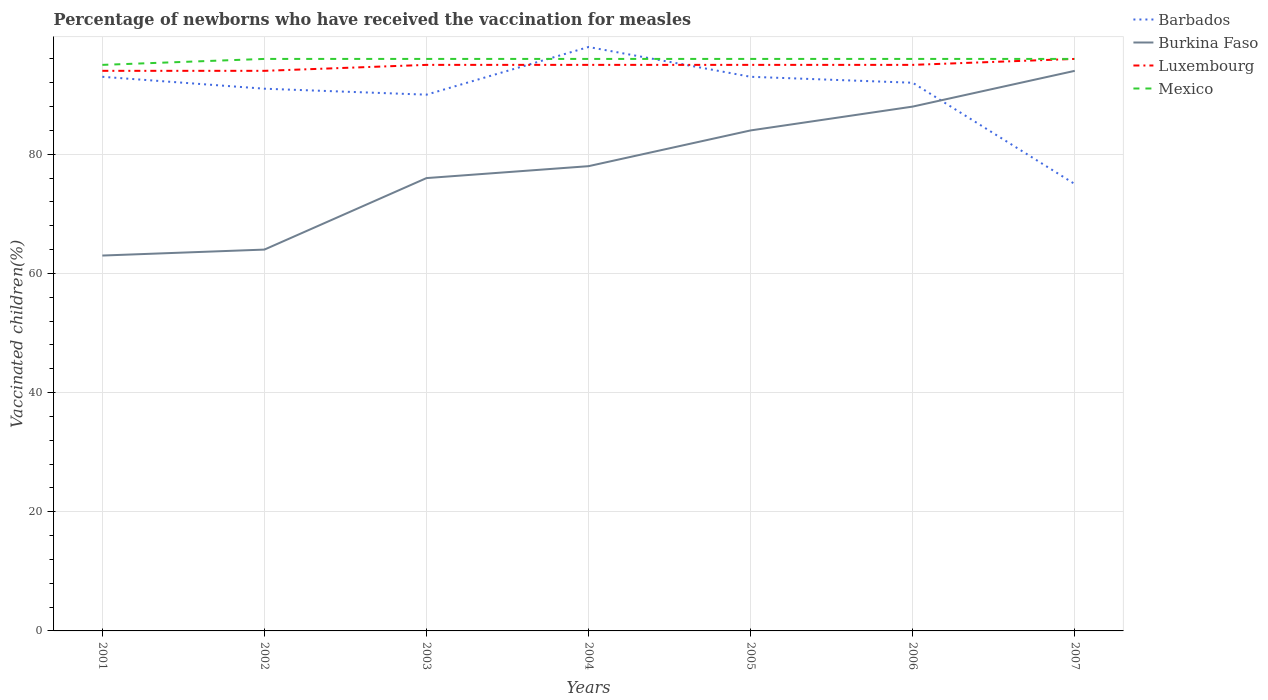Does the line corresponding to Mexico intersect with the line corresponding to Barbados?
Offer a very short reply. Yes. Across all years, what is the maximum percentage of vaccinated children in Barbados?
Give a very brief answer. 75. In which year was the percentage of vaccinated children in Mexico maximum?
Provide a short and direct response. 2001. What is the total percentage of vaccinated children in Mexico in the graph?
Make the answer very short. 0. What is the difference between the highest and the second highest percentage of vaccinated children in Mexico?
Your answer should be compact. 1. What is the difference between the highest and the lowest percentage of vaccinated children in Luxembourg?
Provide a short and direct response. 5. Is the percentage of vaccinated children in Burkina Faso strictly greater than the percentage of vaccinated children in Mexico over the years?
Offer a very short reply. Yes. How many years are there in the graph?
Provide a succinct answer. 7. Are the values on the major ticks of Y-axis written in scientific E-notation?
Your response must be concise. No. Does the graph contain grids?
Give a very brief answer. Yes. Where does the legend appear in the graph?
Your answer should be compact. Top right. How many legend labels are there?
Provide a short and direct response. 4. What is the title of the graph?
Ensure brevity in your answer.  Percentage of newborns who have received the vaccination for measles. What is the label or title of the X-axis?
Your answer should be compact. Years. What is the label or title of the Y-axis?
Provide a short and direct response. Vaccinated children(%). What is the Vaccinated children(%) in Barbados in 2001?
Make the answer very short. 93. What is the Vaccinated children(%) of Luxembourg in 2001?
Keep it short and to the point. 94. What is the Vaccinated children(%) in Barbados in 2002?
Offer a terse response. 91. What is the Vaccinated children(%) of Burkina Faso in 2002?
Offer a terse response. 64. What is the Vaccinated children(%) of Luxembourg in 2002?
Give a very brief answer. 94. What is the Vaccinated children(%) of Mexico in 2002?
Your answer should be compact. 96. What is the Vaccinated children(%) in Barbados in 2003?
Your answer should be very brief. 90. What is the Vaccinated children(%) in Mexico in 2003?
Keep it short and to the point. 96. What is the Vaccinated children(%) of Barbados in 2004?
Make the answer very short. 98. What is the Vaccinated children(%) of Luxembourg in 2004?
Give a very brief answer. 95. What is the Vaccinated children(%) in Mexico in 2004?
Make the answer very short. 96. What is the Vaccinated children(%) in Barbados in 2005?
Ensure brevity in your answer.  93. What is the Vaccinated children(%) in Mexico in 2005?
Provide a short and direct response. 96. What is the Vaccinated children(%) of Barbados in 2006?
Your response must be concise. 92. What is the Vaccinated children(%) of Luxembourg in 2006?
Your answer should be compact. 95. What is the Vaccinated children(%) of Mexico in 2006?
Ensure brevity in your answer.  96. What is the Vaccinated children(%) of Burkina Faso in 2007?
Offer a terse response. 94. What is the Vaccinated children(%) of Luxembourg in 2007?
Offer a very short reply. 96. What is the Vaccinated children(%) of Mexico in 2007?
Your answer should be very brief. 96. Across all years, what is the maximum Vaccinated children(%) in Burkina Faso?
Give a very brief answer. 94. Across all years, what is the maximum Vaccinated children(%) of Luxembourg?
Provide a short and direct response. 96. Across all years, what is the maximum Vaccinated children(%) in Mexico?
Offer a terse response. 96. Across all years, what is the minimum Vaccinated children(%) in Burkina Faso?
Your response must be concise. 63. Across all years, what is the minimum Vaccinated children(%) of Luxembourg?
Give a very brief answer. 94. Across all years, what is the minimum Vaccinated children(%) in Mexico?
Offer a terse response. 95. What is the total Vaccinated children(%) of Barbados in the graph?
Give a very brief answer. 632. What is the total Vaccinated children(%) of Burkina Faso in the graph?
Your answer should be compact. 547. What is the total Vaccinated children(%) in Luxembourg in the graph?
Your response must be concise. 664. What is the total Vaccinated children(%) in Mexico in the graph?
Give a very brief answer. 671. What is the difference between the Vaccinated children(%) in Barbados in 2001 and that in 2002?
Provide a short and direct response. 2. What is the difference between the Vaccinated children(%) of Luxembourg in 2001 and that in 2002?
Keep it short and to the point. 0. What is the difference between the Vaccinated children(%) in Mexico in 2001 and that in 2002?
Provide a succinct answer. -1. What is the difference between the Vaccinated children(%) in Barbados in 2001 and that in 2003?
Provide a succinct answer. 3. What is the difference between the Vaccinated children(%) in Barbados in 2001 and that in 2004?
Give a very brief answer. -5. What is the difference between the Vaccinated children(%) in Luxembourg in 2001 and that in 2004?
Your answer should be compact. -1. What is the difference between the Vaccinated children(%) of Mexico in 2001 and that in 2004?
Your response must be concise. -1. What is the difference between the Vaccinated children(%) of Burkina Faso in 2001 and that in 2005?
Your answer should be very brief. -21. What is the difference between the Vaccinated children(%) of Luxembourg in 2001 and that in 2005?
Your answer should be very brief. -1. What is the difference between the Vaccinated children(%) of Mexico in 2001 and that in 2005?
Your answer should be compact. -1. What is the difference between the Vaccinated children(%) of Luxembourg in 2001 and that in 2006?
Ensure brevity in your answer.  -1. What is the difference between the Vaccinated children(%) in Mexico in 2001 and that in 2006?
Provide a succinct answer. -1. What is the difference between the Vaccinated children(%) in Burkina Faso in 2001 and that in 2007?
Provide a short and direct response. -31. What is the difference between the Vaccinated children(%) in Luxembourg in 2001 and that in 2007?
Your response must be concise. -2. What is the difference between the Vaccinated children(%) of Barbados in 2002 and that in 2003?
Provide a succinct answer. 1. What is the difference between the Vaccinated children(%) in Mexico in 2002 and that in 2003?
Make the answer very short. 0. What is the difference between the Vaccinated children(%) of Barbados in 2002 and that in 2004?
Give a very brief answer. -7. What is the difference between the Vaccinated children(%) in Burkina Faso in 2002 and that in 2004?
Your answer should be very brief. -14. What is the difference between the Vaccinated children(%) in Barbados in 2002 and that in 2005?
Give a very brief answer. -2. What is the difference between the Vaccinated children(%) of Luxembourg in 2002 and that in 2005?
Make the answer very short. -1. What is the difference between the Vaccinated children(%) in Mexico in 2002 and that in 2005?
Provide a short and direct response. 0. What is the difference between the Vaccinated children(%) of Barbados in 2002 and that in 2006?
Provide a succinct answer. -1. What is the difference between the Vaccinated children(%) of Luxembourg in 2002 and that in 2006?
Provide a succinct answer. -1. What is the difference between the Vaccinated children(%) in Barbados in 2002 and that in 2007?
Offer a very short reply. 16. What is the difference between the Vaccinated children(%) in Mexico in 2002 and that in 2007?
Keep it short and to the point. 0. What is the difference between the Vaccinated children(%) of Burkina Faso in 2003 and that in 2004?
Ensure brevity in your answer.  -2. What is the difference between the Vaccinated children(%) in Luxembourg in 2003 and that in 2004?
Provide a short and direct response. 0. What is the difference between the Vaccinated children(%) in Mexico in 2003 and that in 2004?
Offer a terse response. 0. What is the difference between the Vaccinated children(%) of Barbados in 2003 and that in 2005?
Your response must be concise. -3. What is the difference between the Vaccinated children(%) of Burkina Faso in 2003 and that in 2006?
Offer a very short reply. -12. What is the difference between the Vaccinated children(%) of Mexico in 2003 and that in 2006?
Keep it short and to the point. 0. What is the difference between the Vaccinated children(%) in Barbados in 2003 and that in 2007?
Keep it short and to the point. 15. What is the difference between the Vaccinated children(%) in Burkina Faso in 2003 and that in 2007?
Your answer should be very brief. -18. What is the difference between the Vaccinated children(%) in Luxembourg in 2004 and that in 2005?
Provide a succinct answer. 0. What is the difference between the Vaccinated children(%) in Mexico in 2004 and that in 2005?
Keep it short and to the point. 0. What is the difference between the Vaccinated children(%) of Burkina Faso in 2004 and that in 2006?
Provide a short and direct response. -10. What is the difference between the Vaccinated children(%) in Luxembourg in 2004 and that in 2006?
Provide a succinct answer. 0. What is the difference between the Vaccinated children(%) in Mexico in 2004 and that in 2006?
Offer a terse response. 0. What is the difference between the Vaccinated children(%) in Mexico in 2004 and that in 2007?
Ensure brevity in your answer.  0. What is the difference between the Vaccinated children(%) in Luxembourg in 2005 and that in 2006?
Your response must be concise. 0. What is the difference between the Vaccinated children(%) of Barbados in 2005 and that in 2007?
Your answer should be compact. 18. What is the difference between the Vaccinated children(%) of Burkina Faso in 2005 and that in 2007?
Provide a short and direct response. -10. What is the difference between the Vaccinated children(%) in Luxembourg in 2005 and that in 2007?
Your answer should be very brief. -1. What is the difference between the Vaccinated children(%) in Mexico in 2005 and that in 2007?
Your answer should be compact. 0. What is the difference between the Vaccinated children(%) in Burkina Faso in 2006 and that in 2007?
Give a very brief answer. -6. What is the difference between the Vaccinated children(%) of Barbados in 2001 and the Vaccinated children(%) of Luxembourg in 2002?
Make the answer very short. -1. What is the difference between the Vaccinated children(%) of Barbados in 2001 and the Vaccinated children(%) of Mexico in 2002?
Ensure brevity in your answer.  -3. What is the difference between the Vaccinated children(%) of Burkina Faso in 2001 and the Vaccinated children(%) of Luxembourg in 2002?
Make the answer very short. -31. What is the difference between the Vaccinated children(%) in Burkina Faso in 2001 and the Vaccinated children(%) in Mexico in 2002?
Make the answer very short. -33. What is the difference between the Vaccinated children(%) of Barbados in 2001 and the Vaccinated children(%) of Luxembourg in 2003?
Your answer should be compact. -2. What is the difference between the Vaccinated children(%) of Burkina Faso in 2001 and the Vaccinated children(%) of Luxembourg in 2003?
Your answer should be very brief. -32. What is the difference between the Vaccinated children(%) of Burkina Faso in 2001 and the Vaccinated children(%) of Mexico in 2003?
Your answer should be very brief. -33. What is the difference between the Vaccinated children(%) of Barbados in 2001 and the Vaccinated children(%) of Burkina Faso in 2004?
Keep it short and to the point. 15. What is the difference between the Vaccinated children(%) of Burkina Faso in 2001 and the Vaccinated children(%) of Luxembourg in 2004?
Ensure brevity in your answer.  -32. What is the difference between the Vaccinated children(%) of Burkina Faso in 2001 and the Vaccinated children(%) of Mexico in 2004?
Ensure brevity in your answer.  -33. What is the difference between the Vaccinated children(%) of Luxembourg in 2001 and the Vaccinated children(%) of Mexico in 2004?
Your answer should be very brief. -2. What is the difference between the Vaccinated children(%) of Barbados in 2001 and the Vaccinated children(%) of Burkina Faso in 2005?
Give a very brief answer. 9. What is the difference between the Vaccinated children(%) of Barbados in 2001 and the Vaccinated children(%) of Luxembourg in 2005?
Make the answer very short. -2. What is the difference between the Vaccinated children(%) in Barbados in 2001 and the Vaccinated children(%) in Mexico in 2005?
Ensure brevity in your answer.  -3. What is the difference between the Vaccinated children(%) of Burkina Faso in 2001 and the Vaccinated children(%) of Luxembourg in 2005?
Offer a very short reply. -32. What is the difference between the Vaccinated children(%) in Burkina Faso in 2001 and the Vaccinated children(%) in Mexico in 2005?
Give a very brief answer. -33. What is the difference between the Vaccinated children(%) of Barbados in 2001 and the Vaccinated children(%) of Luxembourg in 2006?
Your answer should be very brief. -2. What is the difference between the Vaccinated children(%) of Burkina Faso in 2001 and the Vaccinated children(%) of Luxembourg in 2006?
Ensure brevity in your answer.  -32. What is the difference between the Vaccinated children(%) in Burkina Faso in 2001 and the Vaccinated children(%) in Mexico in 2006?
Provide a short and direct response. -33. What is the difference between the Vaccinated children(%) in Barbados in 2001 and the Vaccinated children(%) in Burkina Faso in 2007?
Your answer should be very brief. -1. What is the difference between the Vaccinated children(%) in Burkina Faso in 2001 and the Vaccinated children(%) in Luxembourg in 2007?
Your answer should be very brief. -33. What is the difference between the Vaccinated children(%) in Burkina Faso in 2001 and the Vaccinated children(%) in Mexico in 2007?
Make the answer very short. -33. What is the difference between the Vaccinated children(%) of Barbados in 2002 and the Vaccinated children(%) of Burkina Faso in 2003?
Keep it short and to the point. 15. What is the difference between the Vaccinated children(%) of Barbados in 2002 and the Vaccinated children(%) of Mexico in 2003?
Ensure brevity in your answer.  -5. What is the difference between the Vaccinated children(%) in Burkina Faso in 2002 and the Vaccinated children(%) in Luxembourg in 2003?
Ensure brevity in your answer.  -31. What is the difference between the Vaccinated children(%) of Burkina Faso in 2002 and the Vaccinated children(%) of Mexico in 2003?
Provide a succinct answer. -32. What is the difference between the Vaccinated children(%) in Barbados in 2002 and the Vaccinated children(%) in Mexico in 2004?
Ensure brevity in your answer.  -5. What is the difference between the Vaccinated children(%) of Burkina Faso in 2002 and the Vaccinated children(%) of Luxembourg in 2004?
Keep it short and to the point. -31. What is the difference between the Vaccinated children(%) in Burkina Faso in 2002 and the Vaccinated children(%) in Mexico in 2004?
Your answer should be compact. -32. What is the difference between the Vaccinated children(%) of Luxembourg in 2002 and the Vaccinated children(%) of Mexico in 2004?
Make the answer very short. -2. What is the difference between the Vaccinated children(%) of Barbados in 2002 and the Vaccinated children(%) of Luxembourg in 2005?
Make the answer very short. -4. What is the difference between the Vaccinated children(%) of Barbados in 2002 and the Vaccinated children(%) of Mexico in 2005?
Provide a succinct answer. -5. What is the difference between the Vaccinated children(%) in Burkina Faso in 2002 and the Vaccinated children(%) in Luxembourg in 2005?
Ensure brevity in your answer.  -31. What is the difference between the Vaccinated children(%) in Burkina Faso in 2002 and the Vaccinated children(%) in Mexico in 2005?
Your answer should be compact. -32. What is the difference between the Vaccinated children(%) of Luxembourg in 2002 and the Vaccinated children(%) of Mexico in 2005?
Offer a terse response. -2. What is the difference between the Vaccinated children(%) of Barbados in 2002 and the Vaccinated children(%) of Burkina Faso in 2006?
Provide a short and direct response. 3. What is the difference between the Vaccinated children(%) in Barbados in 2002 and the Vaccinated children(%) in Mexico in 2006?
Offer a terse response. -5. What is the difference between the Vaccinated children(%) of Burkina Faso in 2002 and the Vaccinated children(%) of Luxembourg in 2006?
Make the answer very short. -31. What is the difference between the Vaccinated children(%) of Burkina Faso in 2002 and the Vaccinated children(%) of Mexico in 2006?
Give a very brief answer. -32. What is the difference between the Vaccinated children(%) of Barbados in 2002 and the Vaccinated children(%) of Luxembourg in 2007?
Offer a terse response. -5. What is the difference between the Vaccinated children(%) of Burkina Faso in 2002 and the Vaccinated children(%) of Luxembourg in 2007?
Your answer should be very brief. -32. What is the difference between the Vaccinated children(%) of Burkina Faso in 2002 and the Vaccinated children(%) of Mexico in 2007?
Keep it short and to the point. -32. What is the difference between the Vaccinated children(%) of Barbados in 2003 and the Vaccinated children(%) of Burkina Faso in 2004?
Provide a succinct answer. 12. What is the difference between the Vaccinated children(%) of Barbados in 2003 and the Vaccinated children(%) of Luxembourg in 2004?
Make the answer very short. -5. What is the difference between the Vaccinated children(%) in Burkina Faso in 2003 and the Vaccinated children(%) in Luxembourg in 2004?
Give a very brief answer. -19. What is the difference between the Vaccinated children(%) of Luxembourg in 2003 and the Vaccinated children(%) of Mexico in 2004?
Provide a succinct answer. -1. What is the difference between the Vaccinated children(%) in Barbados in 2003 and the Vaccinated children(%) in Mexico in 2005?
Make the answer very short. -6. What is the difference between the Vaccinated children(%) of Barbados in 2003 and the Vaccinated children(%) of Luxembourg in 2006?
Give a very brief answer. -5. What is the difference between the Vaccinated children(%) of Burkina Faso in 2003 and the Vaccinated children(%) of Mexico in 2006?
Offer a very short reply. -20. What is the difference between the Vaccinated children(%) in Luxembourg in 2003 and the Vaccinated children(%) in Mexico in 2006?
Your response must be concise. -1. What is the difference between the Vaccinated children(%) in Barbados in 2003 and the Vaccinated children(%) in Luxembourg in 2007?
Make the answer very short. -6. What is the difference between the Vaccinated children(%) in Barbados in 2003 and the Vaccinated children(%) in Mexico in 2007?
Provide a succinct answer. -6. What is the difference between the Vaccinated children(%) of Burkina Faso in 2003 and the Vaccinated children(%) of Mexico in 2007?
Keep it short and to the point. -20. What is the difference between the Vaccinated children(%) of Luxembourg in 2003 and the Vaccinated children(%) of Mexico in 2007?
Your answer should be very brief. -1. What is the difference between the Vaccinated children(%) in Burkina Faso in 2004 and the Vaccinated children(%) in Luxembourg in 2005?
Your answer should be very brief. -17. What is the difference between the Vaccinated children(%) in Luxembourg in 2004 and the Vaccinated children(%) in Mexico in 2005?
Provide a short and direct response. -1. What is the difference between the Vaccinated children(%) of Barbados in 2004 and the Vaccinated children(%) of Burkina Faso in 2006?
Offer a very short reply. 10. What is the difference between the Vaccinated children(%) in Barbados in 2004 and the Vaccinated children(%) in Mexico in 2006?
Give a very brief answer. 2. What is the difference between the Vaccinated children(%) in Burkina Faso in 2004 and the Vaccinated children(%) in Luxembourg in 2006?
Make the answer very short. -17. What is the difference between the Vaccinated children(%) of Luxembourg in 2004 and the Vaccinated children(%) of Mexico in 2006?
Your answer should be compact. -1. What is the difference between the Vaccinated children(%) of Barbados in 2004 and the Vaccinated children(%) of Luxembourg in 2007?
Provide a succinct answer. 2. What is the difference between the Vaccinated children(%) of Barbados in 2004 and the Vaccinated children(%) of Mexico in 2007?
Give a very brief answer. 2. What is the difference between the Vaccinated children(%) of Burkina Faso in 2004 and the Vaccinated children(%) of Luxembourg in 2007?
Your answer should be compact. -18. What is the difference between the Vaccinated children(%) in Luxembourg in 2004 and the Vaccinated children(%) in Mexico in 2007?
Make the answer very short. -1. What is the difference between the Vaccinated children(%) in Barbados in 2005 and the Vaccinated children(%) in Burkina Faso in 2006?
Provide a short and direct response. 5. What is the difference between the Vaccinated children(%) in Barbados in 2005 and the Vaccinated children(%) in Luxembourg in 2006?
Your answer should be compact. -2. What is the difference between the Vaccinated children(%) of Barbados in 2005 and the Vaccinated children(%) of Mexico in 2006?
Offer a terse response. -3. What is the difference between the Vaccinated children(%) in Barbados in 2005 and the Vaccinated children(%) in Luxembourg in 2007?
Your answer should be compact. -3. What is the difference between the Vaccinated children(%) of Barbados in 2006 and the Vaccinated children(%) of Luxembourg in 2007?
Ensure brevity in your answer.  -4. What is the difference between the Vaccinated children(%) in Burkina Faso in 2006 and the Vaccinated children(%) in Luxembourg in 2007?
Your answer should be very brief. -8. What is the difference between the Vaccinated children(%) of Luxembourg in 2006 and the Vaccinated children(%) of Mexico in 2007?
Your response must be concise. -1. What is the average Vaccinated children(%) of Barbados per year?
Your answer should be very brief. 90.29. What is the average Vaccinated children(%) in Burkina Faso per year?
Make the answer very short. 78.14. What is the average Vaccinated children(%) of Luxembourg per year?
Provide a short and direct response. 94.86. What is the average Vaccinated children(%) in Mexico per year?
Your answer should be compact. 95.86. In the year 2001, what is the difference between the Vaccinated children(%) of Barbados and Vaccinated children(%) of Mexico?
Provide a succinct answer. -2. In the year 2001, what is the difference between the Vaccinated children(%) of Burkina Faso and Vaccinated children(%) of Luxembourg?
Offer a terse response. -31. In the year 2001, what is the difference between the Vaccinated children(%) in Burkina Faso and Vaccinated children(%) in Mexico?
Keep it short and to the point. -32. In the year 2002, what is the difference between the Vaccinated children(%) of Barbados and Vaccinated children(%) of Burkina Faso?
Keep it short and to the point. 27. In the year 2002, what is the difference between the Vaccinated children(%) in Barbados and Vaccinated children(%) in Luxembourg?
Your response must be concise. -3. In the year 2002, what is the difference between the Vaccinated children(%) in Burkina Faso and Vaccinated children(%) in Luxembourg?
Provide a succinct answer. -30. In the year 2002, what is the difference between the Vaccinated children(%) of Burkina Faso and Vaccinated children(%) of Mexico?
Keep it short and to the point. -32. In the year 2003, what is the difference between the Vaccinated children(%) in Barbados and Vaccinated children(%) in Luxembourg?
Offer a very short reply. -5. In the year 2003, what is the difference between the Vaccinated children(%) in Burkina Faso and Vaccinated children(%) in Mexico?
Your answer should be compact. -20. In the year 2004, what is the difference between the Vaccinated children(%) in Barbados and Vaccinated children(%) in Luxembourg?
Keep it short and to the point. 3. In the year 2004, what is the difference between the Vaccinated children(%) of Luxembourg and Vaccinated children(%) of Mexico?
Make the answer very short. -1. In the year 2005, what is the difference between the Vaccinated children(%) of Luxembourg and Vaccinated children(%) of Mexico?
Offer a very short reply. -1. In the year 2006, what is the difference between the Vaccinated children(%) of Barbados and Vaccinated children(%) of Burkina Faso?
Ensure brevity in your answer.  4. In the year 2006, what is the difference between the Vaccinated children(%) in Barbados and Vaccinated children(%) in Luxembourg?
Give a very brief answer. -3. In the year 2006, what is the difference between the Vaccinated children(%) of Barbados and Vaccinated children(%) of Mexico?
Make the answer very short. -4. In the year 2006, what is the difference between the Vaccinated children(%) in Burkina Faso and Vaccinated children(%) in Mexico?
Ensure brevity in your answer.  -8. In the year 2007, what is the difference between the Vaccinated children(%) of Barbados and Vaccinated children(%) of Burkina Faso?
Your answer should be very brief. -19. In the year 2007, what is the difference between the Vaccinated children(%) of Barbados and Vaccinated children(%) of Luxembourg?
Offer a terse response. -21. In the year 2007, what is the difference between the Vaccinated children(%) in Barbados and Vaccinated children(%) in Mexico?
Give a very brief answer. -21. In the year 2007, what is the difference between the Vaccinated children(%) of Burkina Faso and Vaccinated children(%) of Luxembourg?
Your response must be concise. -2. In the year 2007, what is the difference between the Vaccinated children(%) in Burkina Faso and Vaccinated children(%) in Mexico?
Offer a very short reply. -2. In the year 2007, what is the difference between the Vaccinated children(%) of Luxembourg and Vaccinated children(%) of Mexico?
Your answer should be very brief. 0. What is the ratio of the Vaccinated children(%) of Burkina Faso in 2001 to that in 2002?
Keep it short and to the point. 0.98. What is the ratio of the Vaccinated children(%) in Mexico in 2001 to that in 2002?
Keep it short and to the point. 0.99. What is the ratio of the Vaccinated children(%) in Barbados in 2001 to that in 2003?
Make the answer very short. 1.03. What is the ratio of the Vaccinated children(%) in Burkina Faso in 2001 to that in 2003?
Ensure brevity in your answer.  0.83. What is the ratio of the Vaccinated children(%) of Luxembourg in 2001 to that in 2003?
Give a very brief answer. 0.99. What is the ratio of the Vaccinated children(%) in Barbados in 2001 to that in 2004?
Give a very brief answer. 0.95. What is the ratio of the Vaccinated children(%) in Burkina Faso in 2001 to that in 2004?
Provide a short and direct response. 0.81. What is the ratio of the Vaccinated children(%) of Mexico in 2001 to that in 2004?
Offer a very short reply. 0.99. What is the ratio of the Vaccinated children(%) of Burkina Faso in 2001 to that in 2005?
Provide a succinct answer. 0.75. What is the ratio of the Vaccinated children(%) of Luxembourg in 2001 to that in 2005?
Make the answer very short. 0.99. What is the ratio of the Vaccinated children(%) in Barbados in 2001 to that in 2006?
Ensure brevity in your answer.  1.01. What is the ratio of the Vaccinated children(%) in Burkina Faso in 2001 to that in 2006?
Give a very brief answer. 0.72. What is the ratio of the Vaccinated children(%) in Luxembourg in 2001 to that in 2006?
Your response must be concise. 0.99. What is the ratio of the Vaccinated children(%) of Mexico in 2001 to that in 2006?
Give a very brief answer. 0.99. What is the ratio of the Vaccinated children(%) of Barbados in 2001 to that in 2007?
Keep it short and to the point. 1.24. What is the ratio of the Vaccinated children(%) of Burkina Faso in 2001 to that in 2007?
Offer a very short reply. 0.67. What is the ratio of the Vaccinated children(%) in Luxembourg in 2001 to that in 2007?
Your answer should be compact. 0.98. What is the ratio of the Vaccinated children(%) of Barbados in 2002 to that in 2003?
Your answer should be compact. 1.01. What is the ratio of the Vaccinated children(%) in Burkina Faso in 2002 to that in 2003?
Make the answer very short. 0.84. What is the ratio of the Vaccinated children(%) in Luxembourg in 2002 to that in 2003?
Offer a very short reply. 0.99. What is the ratio of the Vaccinated children(%) in Barbados in 2002 to that in 2004?
Provide a short and direct response. 0.93. What is the ratio of the Vaccinated children(%) in Burkina Faso in 2002 to that in 2004?
Your response must be concise. 0.82. What is the ratio of the Vaccinated children(%) in Luxembourg in 2002 to that in 2004?
Make the answer very short. 0.99. What is the ratio of the Vaccinated children(%) in Barbados in 2002 to that in 2005?
Your response must be concise. 0.98. What is the ratio of the Vaccinated children(%) of Burkina Faso in 2002 to that in 2005?
Your answer should be very brief. 0.76. What is the ratio of the Vaccinated children(%) in Mexico in 2002 to that in 2005?
Your answer should be very brief. 1. What is the ratio of the Vaccinated children(%) of Barbados in 2002 to that in 2006?
Provide a short and direct response. 0.99. What is the ratio of the Vaccinated children(%) in Burkina Faso in 2002 to that in 2006?
Your response must be concise. 0.73. What is the ratio of the Vaccinated children(%) of Luxembourg in 2002 to that in 2006?
Offer a terse response. 0.99. What is the ratio of the Vaccinated children(%) in Barbados in 2002 to that in 2007?
Keep it short and to the point. 1.21. What is the ratio of the Vaccinated children(%) of Burkina Faso in 2002 to that in 2007?
Offer a very short reply. 0.68. What is the ratio of the Vaccinated children(%) of Luxembourg in 2002 to that in 2007?
Keep it short and to the point. 0.98. What is the ratio of the Vaccinated children(%) of Barbados in 2003 to that in 2004?
Offer a very short reply. 0.92. What is the ratio of the Vaccinated children(%) in Burkina Faso in 2003 to that in 2004?
Give a very brief answer. 0.97. What is the ratio of the Vaccinated children(%) of Luxembourg in 2003 to that in 2004?
Ensure brevity in your answer.  1. What is the ratio of the Vaccinated children(%) of Mexico in 2003 to that in 2004?
Provide a short and direct response. 1. What is the ratio of the Vaccinated children(%) in Barbados in 2003 to that in 2005?
Provide a succinct answer. 0.97. What is the ratio of the Vaccinated children(%) in Burkina Faso in 2003 to that in 2005?
Ensure brevity in your answer.  0.9. What is the ratio of the Vaccinated children(%) of Mexico in 2003 to that in 2005?
Offer a terse response. 1. What is the ratio of the Vaccinated children(%) in Barbados in 2003 to that in 2006?
Provide a short and direct response. 0.98. What is the ratio of the Vaccinated children(%) in Burkina Faso in 2003 to that in 2006?
Ensure brevity in your answer.  0.86. What is the ratio of the Vaccinated children(%) in Luxembourg in 2003 to that in 2006?
Your response must be concise. 1. What is the ratio of the Vaccinated children(%) in Barbados in 2003 to that in 2007?
Your answer should be compact. 1.2. What is the ratio of the Vaccinated children(%) in Burkina Faso in 2003 to that in 2007?
Offer a very short reply. 0.81. What is the ratio of the Vaccinated children(%) of Luxembourg in 2003 to that in 2007?
Give a very brief answer. 0.99. What is the ratio of the Vaccinated children(%) of Barbados in 2004 to that in 2005?
Offer a very short reply. 1.05. What is the ratio of the Vaccinated children(%) of Burkina Faso in 2004 to that in 2005?
Keep it short and to the point. 0.93. What is the ratio of the Vaccinated children(%) of Luxembourg in 2004 to that in 2005?
Provide a short and direct response. 1. What is the ratio of the Vaccinated children(%) of Mexico in 2004 to that in 2005?
Ensure brevity in your answer.  1. What is the ratio of the Vaccinated children(%) of Barbados in 2004 to that in 2006?
Make the answer very short. 1.07. What is the ratio of the Vaccinated children(%) in Burkina Faso in 2004 to that in 2006?
Keep it short and to the point. 0.89. What is the ratio of the Vaccinated children(%) of Barbados in 2004 to that in 2007?
Offer a terse response. 1.31. What is the ratio of the Vaccinated children(%) in Burkina Faso in 2004 to that in 2007?
Offer a terse response. 0.83. What is the ratio of the Vaccinated children(%) in Barbados in 2005 to that in 2006?
Offer a very short reply. 1.01. What is the ratio of the Vaccinated children(%) in Burkina Faso in 2005 to that in 2006?
Keep it short and to the point. 0.95. What is the ratio of the Vaccinated children(%) of Luxembourg in 2005 to that in 2006?
Your answer should be very brief. 1. What is the ratio of the Vaccinated children(%) in Mexico in 2005 to that in 2006?
Give a very brief answer. 1. What is the ratio of the Vaccinated children(%) of Barbados in 2005 to that in 2007?
Give a very brief answer. 1.24. What is the ratio of the Vaccinated children(%) in Burkina Faso in 2005 to that in 2007?
Keep it short and to the point. 0.89. What is the ratio of the Vaccinated children(%) of Luxembourg in 2005 to that in 2007?
Offer a terse response. 0.99. What is the ratio of the Vaccinated children(%) of Barbados in 2006 to that in 2007?
Offer a very short reply. 1.23. What is the ratio of the Vaccinated children(%) in Burkina Faso in 2006 to that in 2007?
Your answer should be compact. 0.94. What is the difference between the highest and the second highest Vaccinated children(%) of Barbados?
Your answer should be very brief. 5. What is the difference between the highest and the lowest Vaccinated children(%) in Burkina Faso?
Provide a succinct answer. 31. What is the difference between the highest and the lowest Vaccinated children(%) in Mexico?
Make the answer very short. 1. 